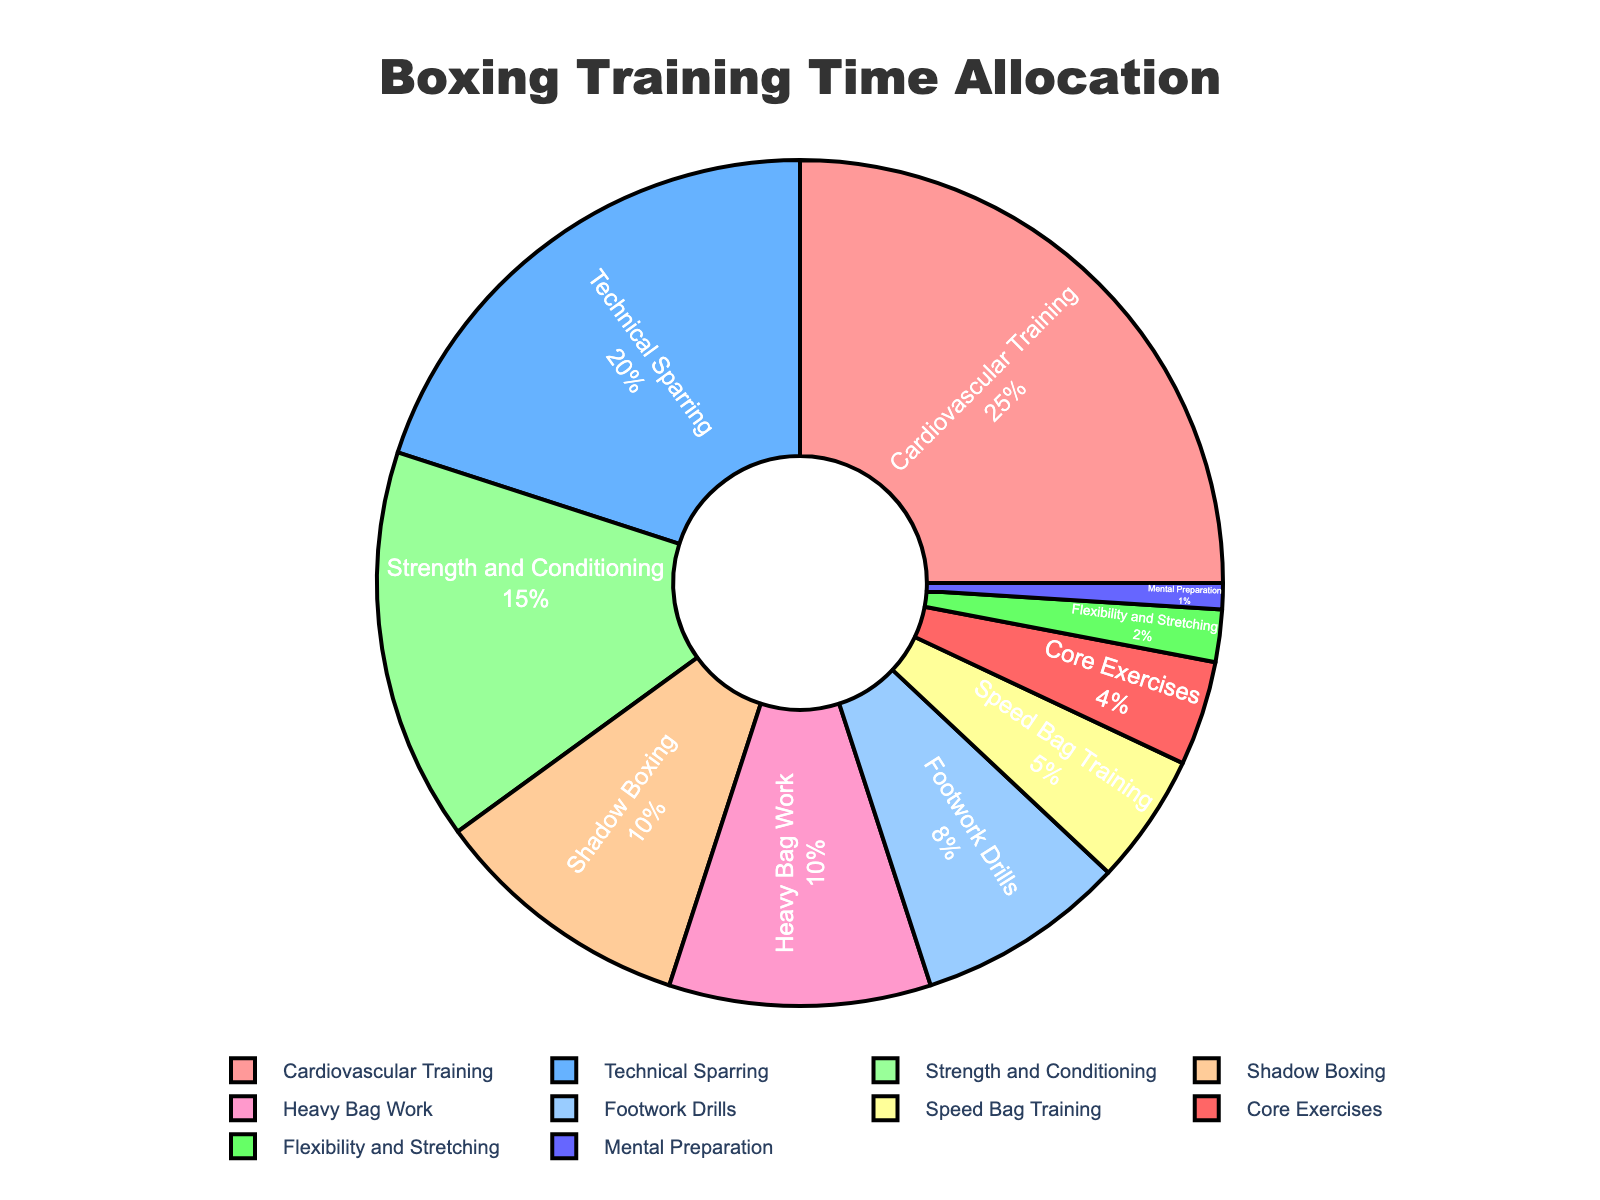What percentage of training time is allocated to Technical Sparring? Look for Technical Sparring in the figure, then note the percentage value associated with it.
Answer: 20% Which aspect has the smallest allocation of training time? Find the aspect with the smallest slice in the pie chart, which corresponds to the smallest percentage value.
Answer: Mental Preparation How much more time is allocated to Cardiovascular Training compared to Speed Bag Training? Subtract the percentage of Speed Bag Training from the percentage of Cardiovascular Training: 25% - 5%
Answer: 20% What is the combined percentage for Heavy Bag Work and Core Exercises? Add the percentages for Heavy Bag Work and Core Exercises: 10% + 4%
Answer: 14% How does the allocation for Strength and Conditioning compare to Footwork Drills? Identify the percentage for both Strength and Conditioning and Footwork Drills, then compare: 15% vs 8%, so Strength and Conditioning is more than Footwork Drills.
Answer: Strength and Conditioning has 7% more Which aspect is allocated more training time: Cardiovascular Training or Technical Sparring? Compare the percentages of Cardiovascular Training (25%) and Technical Sparring (20%), and see which is larger.
Answer: Cardiovascular Training What is the difference in allocation between Shadow Boxing and Strength and Conditioning? Subtract the percentage of Shadow Boxing from the percentage of Strength and Conditioning: 15% - 10%
Answer: 5% Combine the percentages of the top three aspects with the largest allocations. What do you get? Sum the percentages of the top three aspects: Cardiovascular Training (25%), Technical Sparring (20%), and Strength and Conditioning (15%): 25% + 20% + 15%
Answer: 60% What is the total percentage allocated to exercises focusing specifically on agility and speed (Footwork Drills and Speed Bag Training)? Add the percentages for Footwork Drills and Speed Bag Training: 8% + 5%
Answer: 13% Which aspects have an allocation of 10% or more? Identify and list all aspects with percentages 10% or above: Cardiovascular Training (25%), Technical Sparring (20%), Strength and Conditioning (15%), Shadow Boxing (10%), Heavy Bag Work (10%)
Answer: Cardiovascular Training, Technical Sparring, Strength and Conditioning, Shadow Boxing, Heavy Bag Work 